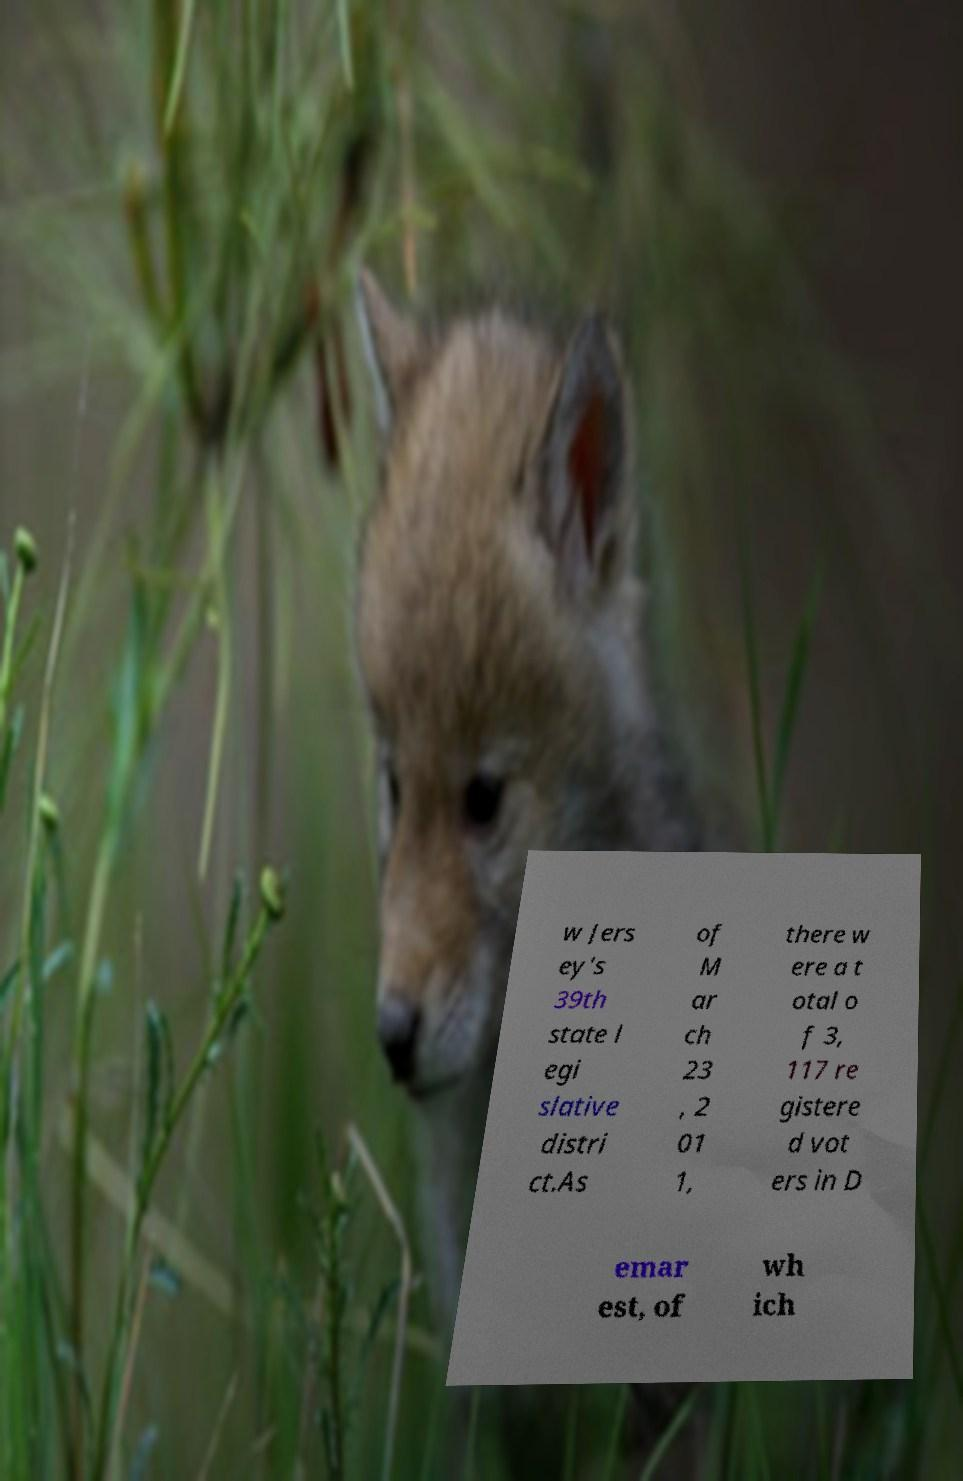There's text embedded in this image that I need extracted. Can you transcribe it verbatim? w Jers ey's 39th state l egi slative distri ct.As of M ar ch 23 , 2 01 1, there w ere a t otal o f 3, 117 re gistere d vot ers in D emar est, of wh ich 